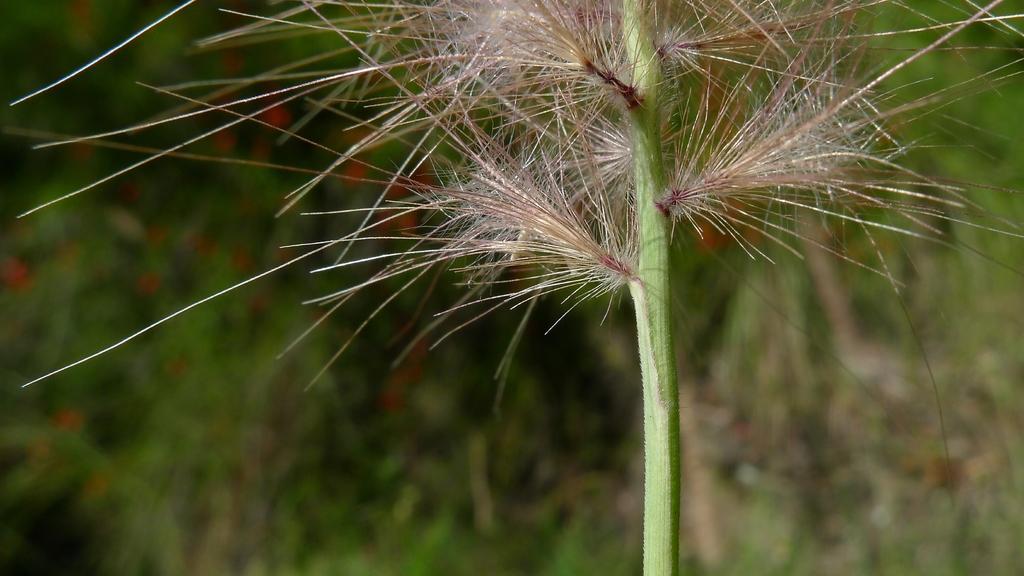In one or two sentences, can you explain what this image depicts? In this picture we can see plant. In the background of the image it is blurry. 